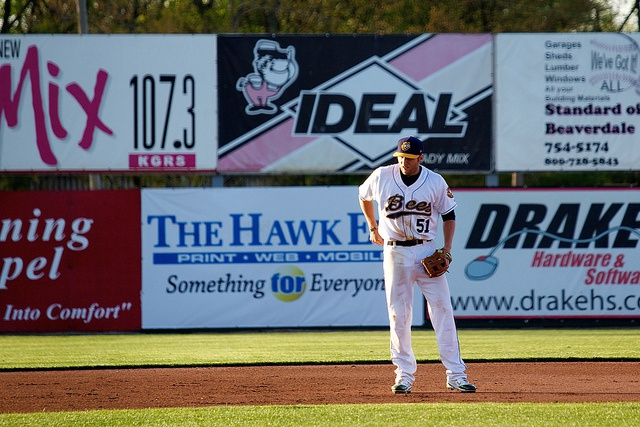Describe the objects in this image and their specific colors. I can see people in olive, darkgray, white, and black tones and baseball glove in olive, maroon, black, and gray tones in this image. 